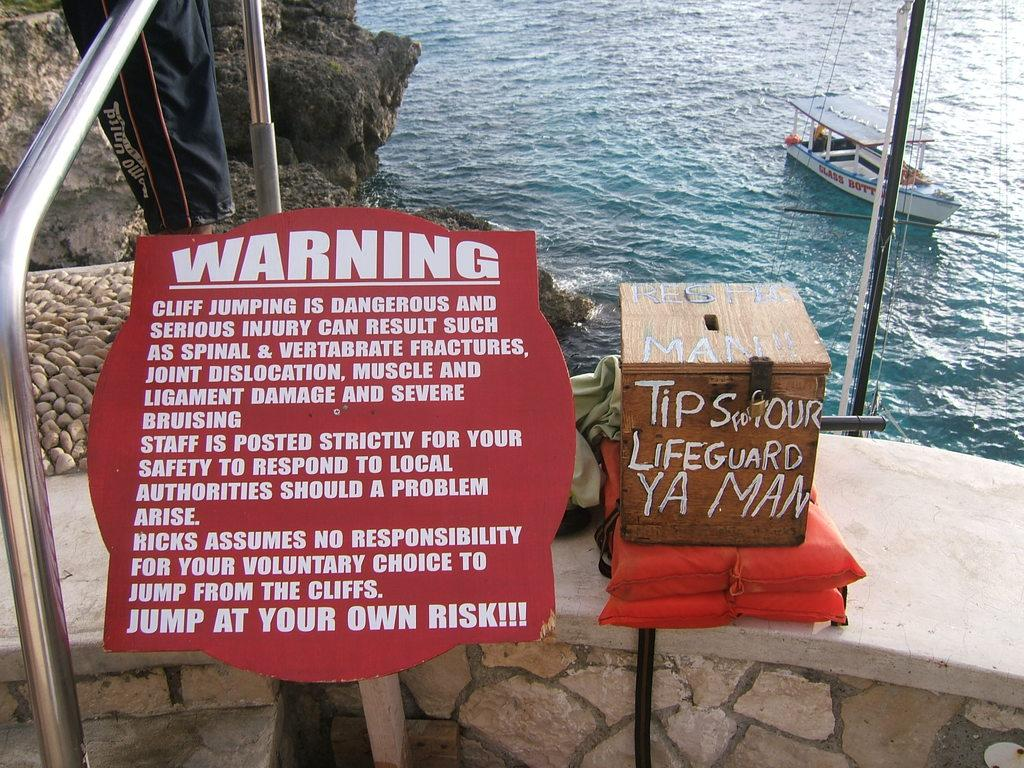What is the main object in the image? There is a board in the image. What else can be seen on the board? There are life jackets and a box placed on the board. Where are these objects located? The board, life jackets, and box are placed on a wall. What can be seen in the background of the image? In the background, there are persons' legs visible, a hill, water, and another board. What type of instrument is being played on the floor in the image? There is no instrument being played on the floor in the image. 